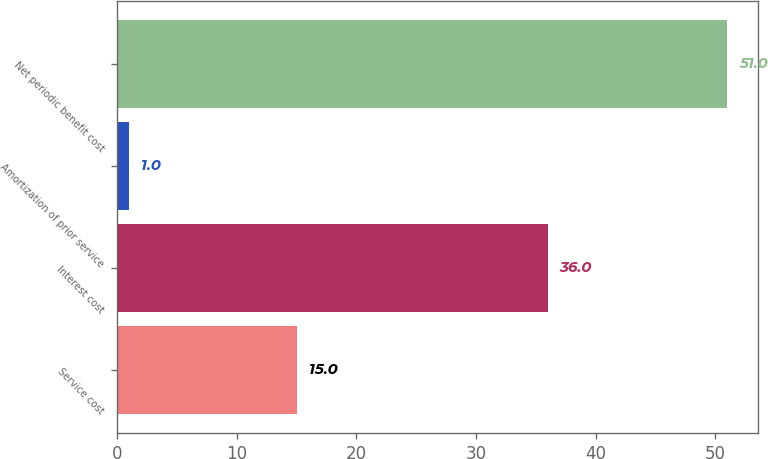Convert chart to OTSL. <chart><loc_0><loc_0><loc_500><loc_500><bar_chart><fcel>Service cost<fcel>Interest cost<fcel>Amortization of prior service<fcel>Net periodic benefit cost<nl><fcel>15<fcel>36<fcel>1<fcel>51<nl></chart> 